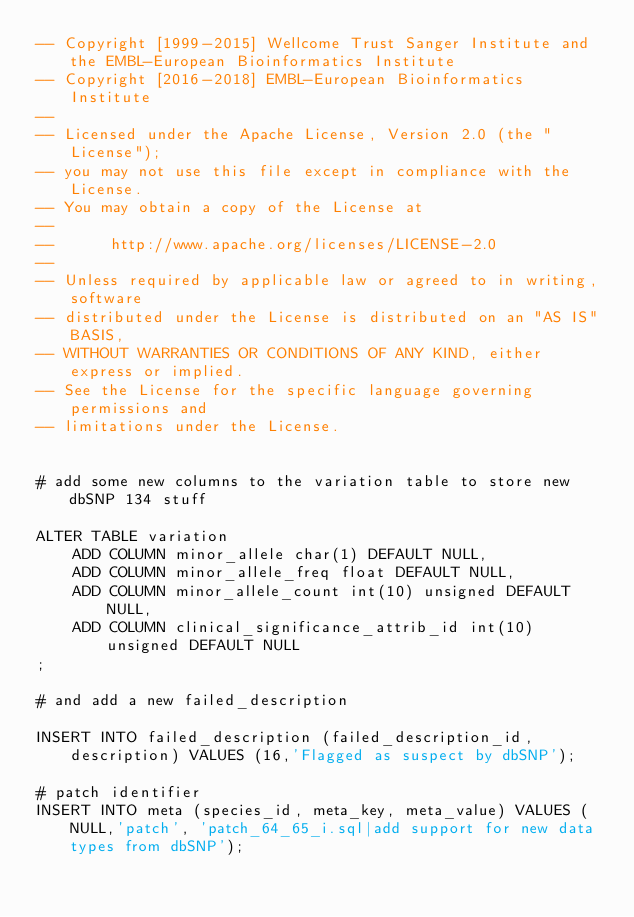<code> <loc_0><loc_0><loc_500><loc_500><_SQL_>-- Copyright [1999-2015] Wellcome Trust Sanger Institute and the EMBL-European Bioinformatics Institute
-- Copyright [2016-2018] EMBL-European Bioinformatics Institute
-- 
-- Licensed under the Apache License, Version 2.0 (the "License");
-- you may not use this file except in compliance with the License.
-- You may obtain a copy of the License at
-- 
--      http://www.apache.org/licenses/LICENSE-2.0
-- 
-- Unless required by applicable law or agreed to in writing, software
-- distributed under the License is distributed on an "AS IS" BASIS,
-- WITHOUT WARRANTIES OR CONDITIONS OF ANY KIND, either express or implied.
-- See the License for the specific language governing permissions and
-- limitations under the License.


# add some new columns to the variation table to store new dbSNP 134 stuff

ALTER TABLE variation 
    ADD COLUMN minor_allele char(1) DEFAULT NULL,
    ADD COLUMN minor_allele_freq float DEFAULT NULL,
    ADD COLUMN minor_allele_count int(10) unsigned DEFAULT NULL, 
    ADD COLUMN clinical_significance_attrib_id int(10) unsigned DEFAULT NULL
;

# and add a new failed_description

INSERT INTO failed_description (failed_description_id,description) VALUES (16,'Flagged as suspect by dbSNP');

# patch identifier
INSERT INTO meta (species_id, meta_key, meta_value) VALUES (NULL,'patch', 'patch_64_65_i.sql|add support for new data types from dbSNP');

</code> 